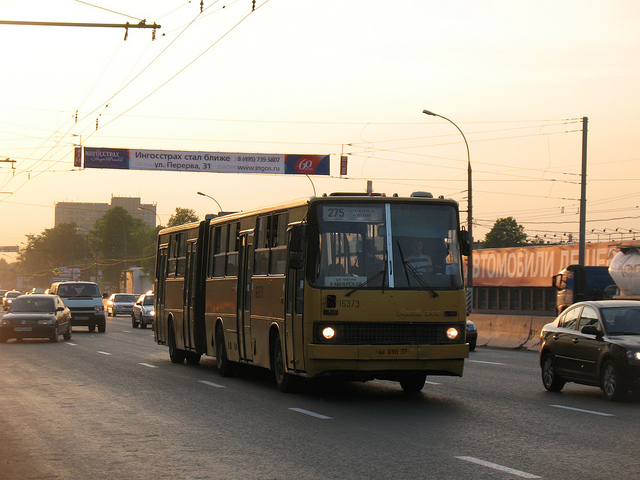Please transcribe the text in this image. 275 